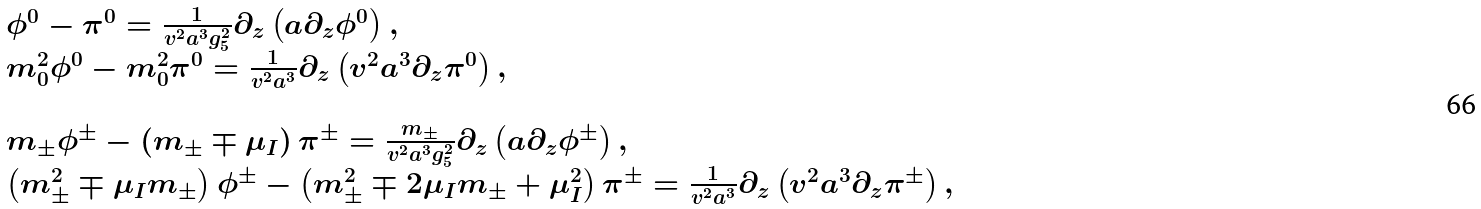Convert formula to latex. <formula><loc_0><loc_0><loc_500><loc_500>\begin{array} { l } \phi ^ { 0 } - \pi ^ { 0 } = \frac { 1 } { v ^ { 2 } a ^ { 3 } g _ { 5 } ^ { 2 } } \partial _ { z } \left ( a \partial _ { z } \phi ^ { 0 } \right ) , \\ m _ { 0 } ^ { 2 } \phi ^ { 0 } - m _ { 0 } ^ { 2 } \pi ^ { 0 } = \frac { 1 } { v ^ { 2 } a ^ { 3 } } \partial _ { z } \left ( v ^ { 2 } a ^ { 3 } \partial _ { z } \pi ^ { 0 } \right ) , \\ \quad \\ m _ { \pm } \phi ^ { \pm } - \left ( m _ { \pm } \mp \mu _ { I } \right ) \pi ^ { \pm } = \frac { m _ { \pm } } { v ^ { 2 } a ^ { 3 } g _ { 5 } ^ { 2 } } \partial _ { z } \left ( a \partial _ { z } \phi ^ { \pm } \right ) , \\ \left ( m _ { \pm } ^ { 2 } \mp \mu _ { I } m _ { \pm } \right ) \phi ^ { \pm } - \left ( m _ { \pm } ^ { 2 } \mp 2 \mu _ { I } m _ { \pm } + \mu _ { I } ^ { 2 } \right ) \pi ^ { \pm } = \frac { 1 } { v ^ { 2 } a ^ { 3 } } \partial _ { z } \left ( v ^ { 2 } a ^ { 3 } \partial _ { z } \pi ^ { \pm } \right ) , \end{array}</formula> 